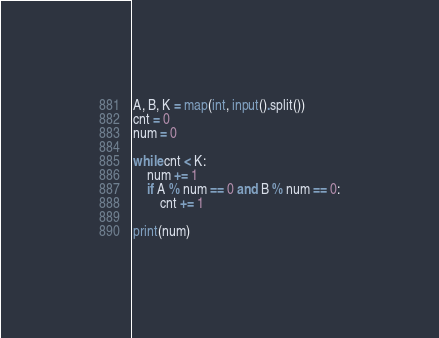Convert code to text. <code><loc_0><loc_0><loc_500><loc_500><_Python_>A, B, K = map(int, input().split())
cnt = 0
num = 0

while cnt < K:
    num += 1
    if A % num == 0 and B % num == 0:
        cnt += 1

print(num)
</code> 